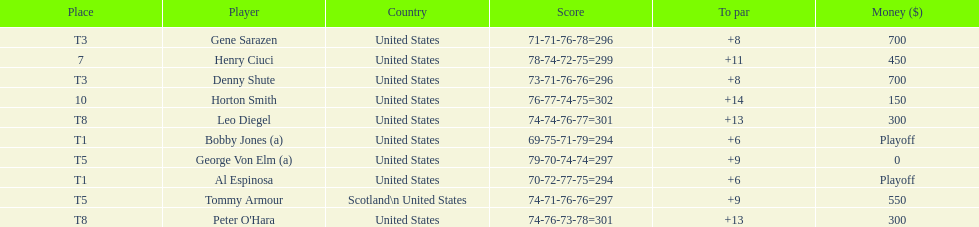How many players represented scotland? 1. 